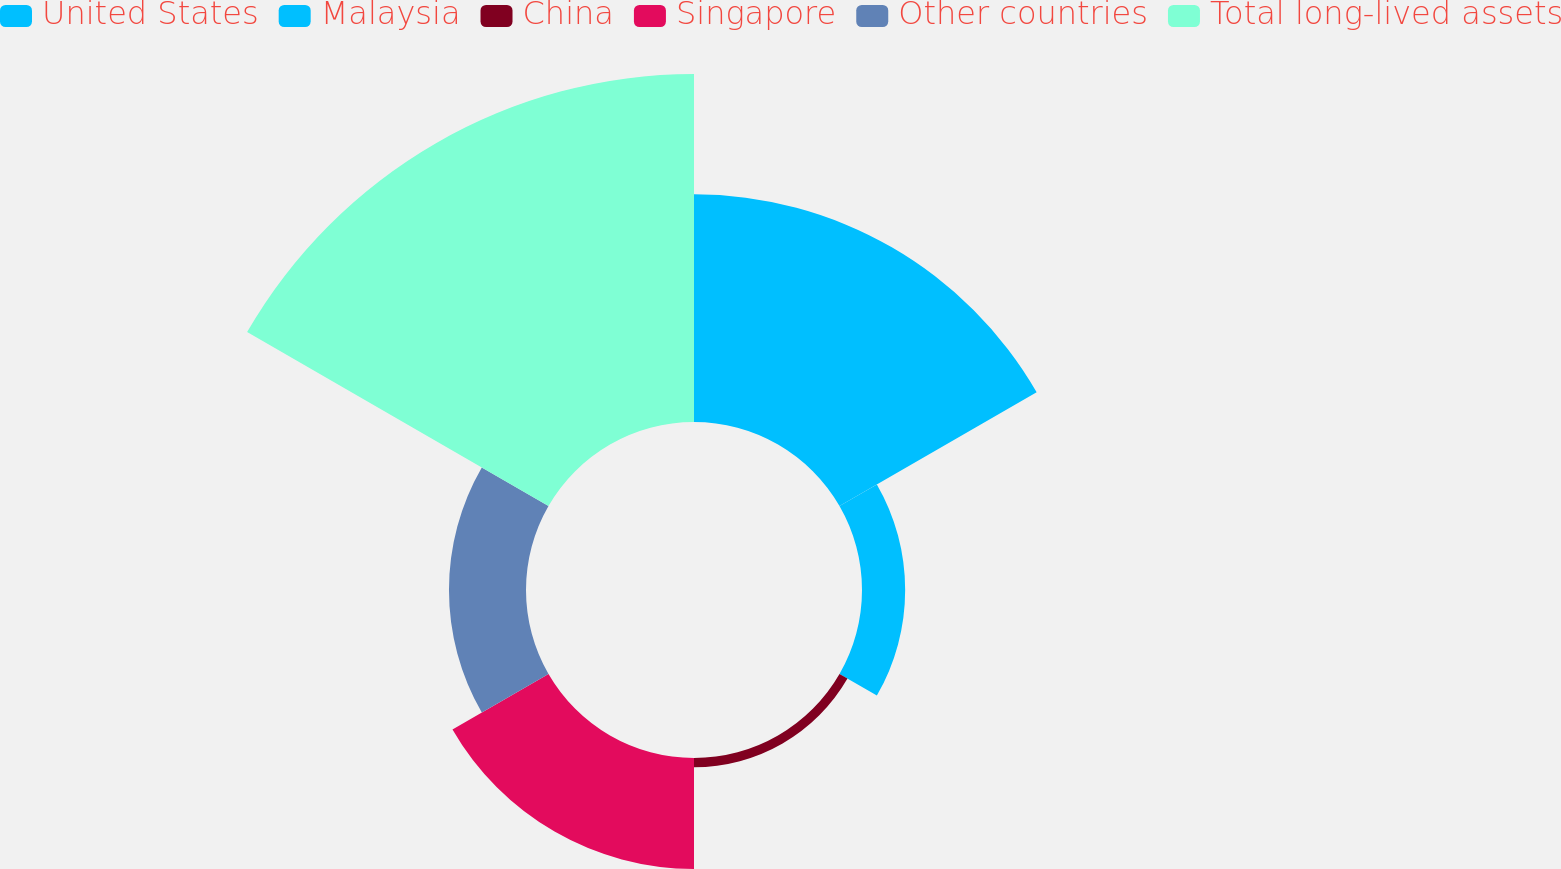<chart> <loc_0><loc_0><loc_500><loc_500><pie_chart><fcel>United States<fcel>Malaysia<fcel>China<fcel>Singapore<fcel>Other countries<fcel>Total long-lived assets<nl><fcel>27.9%<fcel>5.29%<fcel>1.13%<fcel>13.59%<fcel>9.44%<fcel>42.65%<nl></chart> 